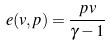Convert formula to latex. <formula><loc_0><loc_0><loc_500><loc_500>e ( v , p ) = \frac { p v } { \gamma - 1 }</formula> 